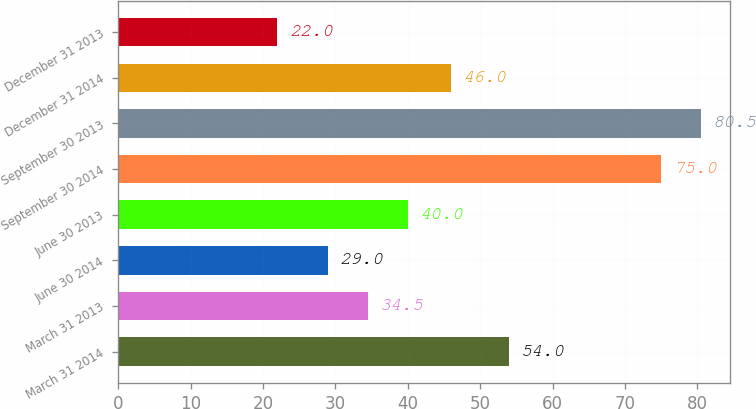Convert chart to OTSL. <chart><loc_0><loc_0><loc_500><loc_500><bar_chart><fcel>March 31 2014<fcel>March 31 2013<fcel>June 30 2014<fcel>June 30 2013<fcel>September 30 2014<fcel>September 30 2013<fcel>December 31 2014<fcel>December 31 2013<nl><fcel>54<fcel>34.5<fcel>29<fcel>40<fcel>75<fcel>80.5<fcel>46<fcel>22<nl></chart> 